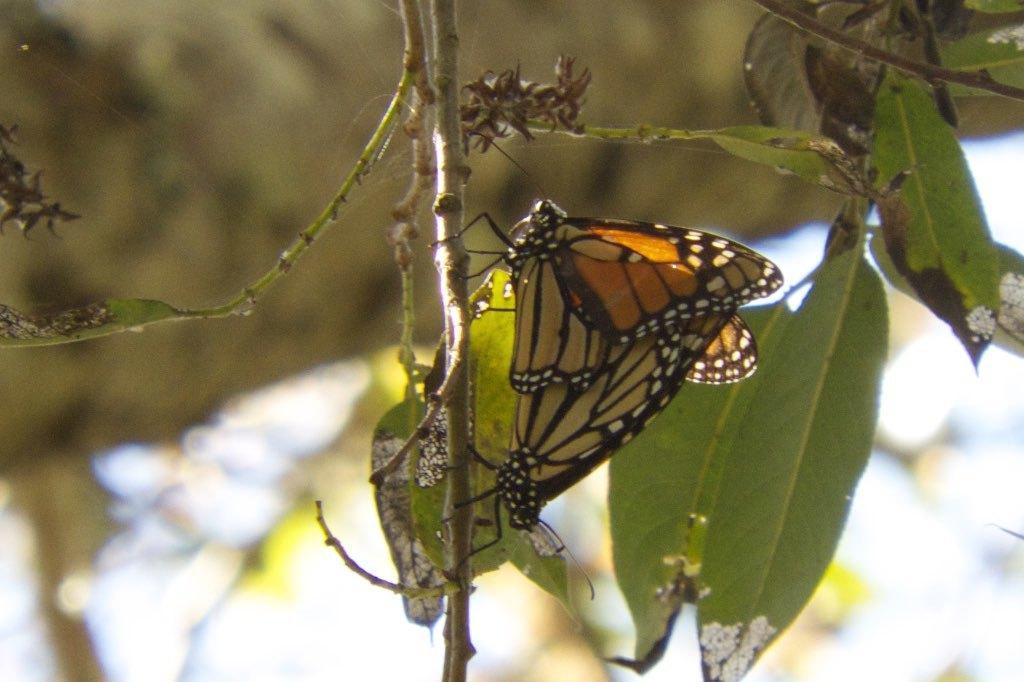Describe this image in one or two sentences. This picture seems to be clicked outside. In the center we can see a butterfly on the stem and we can see the green leaves and some other objects. The background of the image is blurry. 